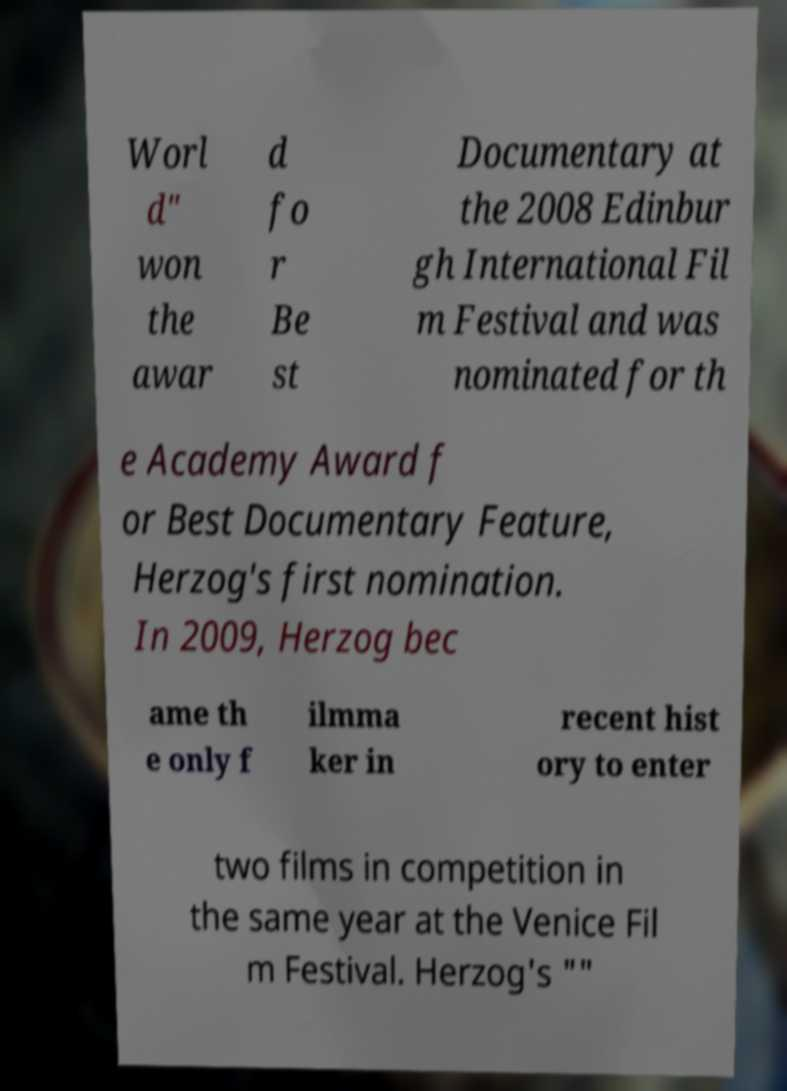There's text embedded in this image that I need extracted. Can you transcribe it verbatim? Worl d" won the awar d fo r Be st Documentary at the 2008 Edinbur gh International Fil m Festival and was nominated for th e Academy Award f or Best Documentary Feature, Herzog's first nomination. In 2009, Herzog bec ame th e only f ilmma ker in recent hist ory to enter two films in competition in the same year at the Venice Fil m Festival. Herzog's "" 